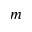Convert formula to latex. <formula><loc_0><loc_0><loc_500><loc_500>m</formula> 